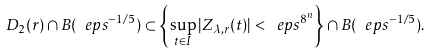Convert formula to latex. <formula><loc_0><loc_0><loc_500><loc_500>D _ { 2 } ( r ) \cap B ( \ e p s ^ { - 1 / 5 } ) \subset \left \{ \sup _ { t \in I } | Z _ { \lambda , r } ( t ) | < \ e p s ^ { 8 ^ { n } } \right \} \cap B ( \ e p s ^ { - 1 / 5 } ) .</formula> 